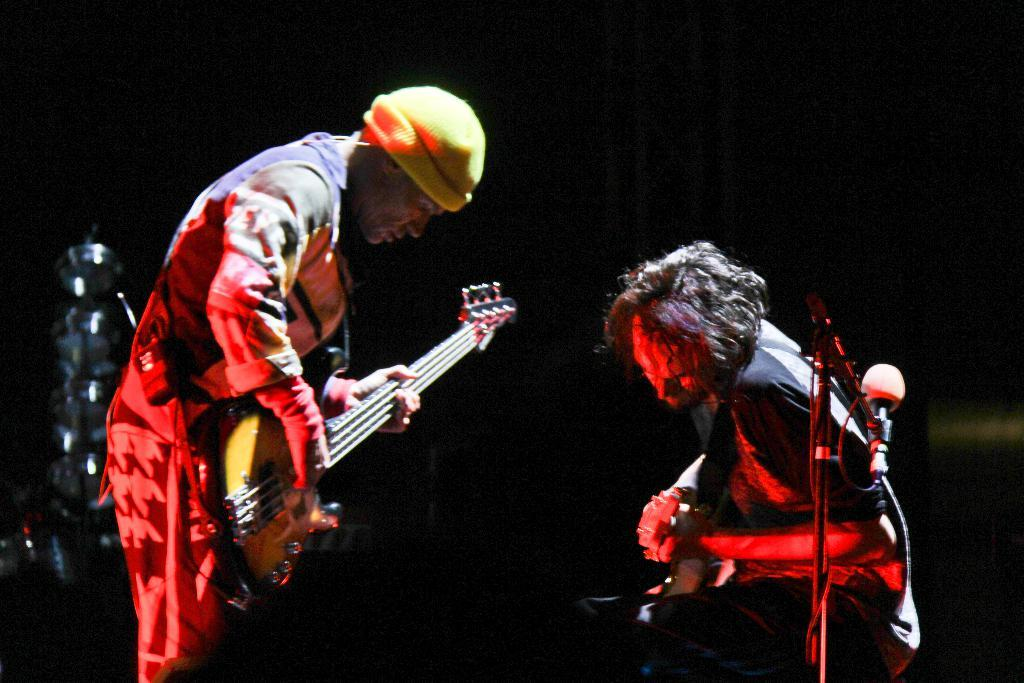How many people are in the image? There are two persons in the image. What are the persons doing in the image? The persons are playing musical instruments. Can you describe any equipment related to sound in the image? Yes, there is a microphone (mic) in the image. What else can be seen in the image besides the persons and the microphone? There is a stand in the image. What type of kite is being flown by the persons in the image? There is no kite present in the image; the persons are playing musical instruments. Who is leading the performance in the image? The provided facts do not indicate a specific leader for the performance. 